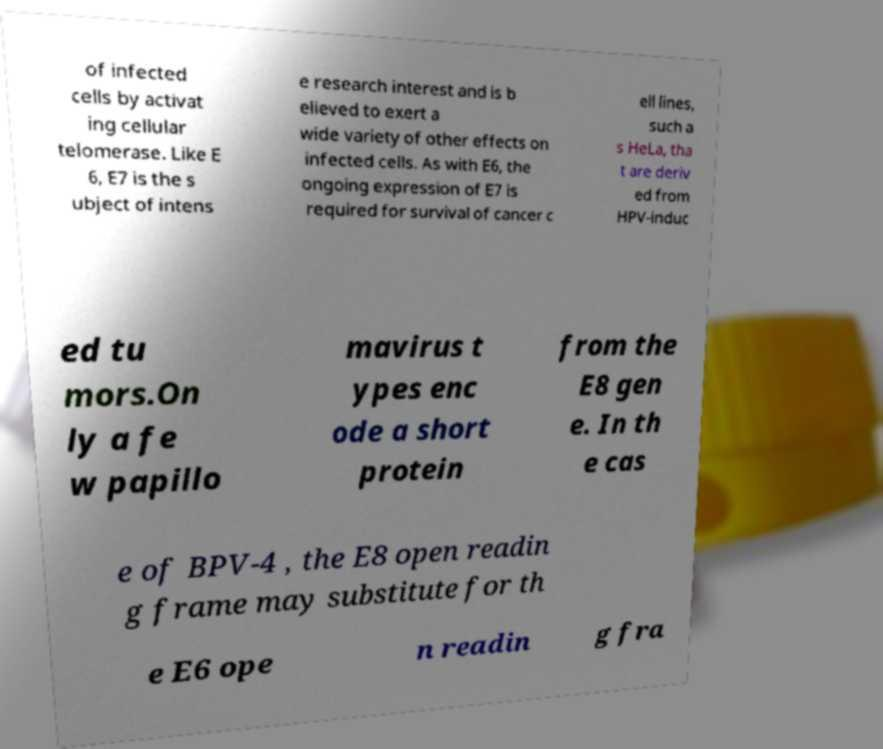There's text embedded in this image that I need extracted. Can you transcribe it verbatim? of infected cells by activat ing cellular telomerase. Like E 6, E7 is the s ubject of intens e research interest and is b elieved to exert a wide variety of other effects on infected cells. As with E6, the ongoing expression of E7 is required for survival of cancer c ell lines, such a s HeLa, tha t are deriv ed from HPV-induc ed tu mors.On ly a fe w papillo mavirus t ypes enc ode a short protein from the E8 gen e. In th e cas e of BPV-4 , the E8 open readin g frame may substitute for th e E6 ope n readin g fra 